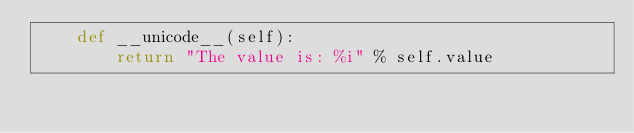<code> <loc_0><loc_0><loc_500><loc_500><_Python_>    def __unicode__(self):
        return "The value is: %i" % self.value
</code> 